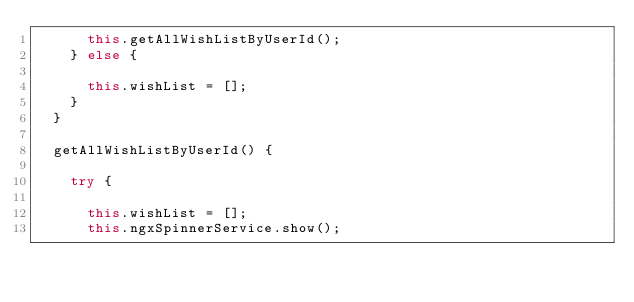<code> <loc_0><loc_0><loc_500><loc_500><_TypeScript_>			this.getAllWishListByUserId();
		} else {

			this.wishList = [];
		}
	}

	getAllWishListByUserId() {

		try {

			this.wishList = [];
			this.ngxSpinnerService.show();</code> 